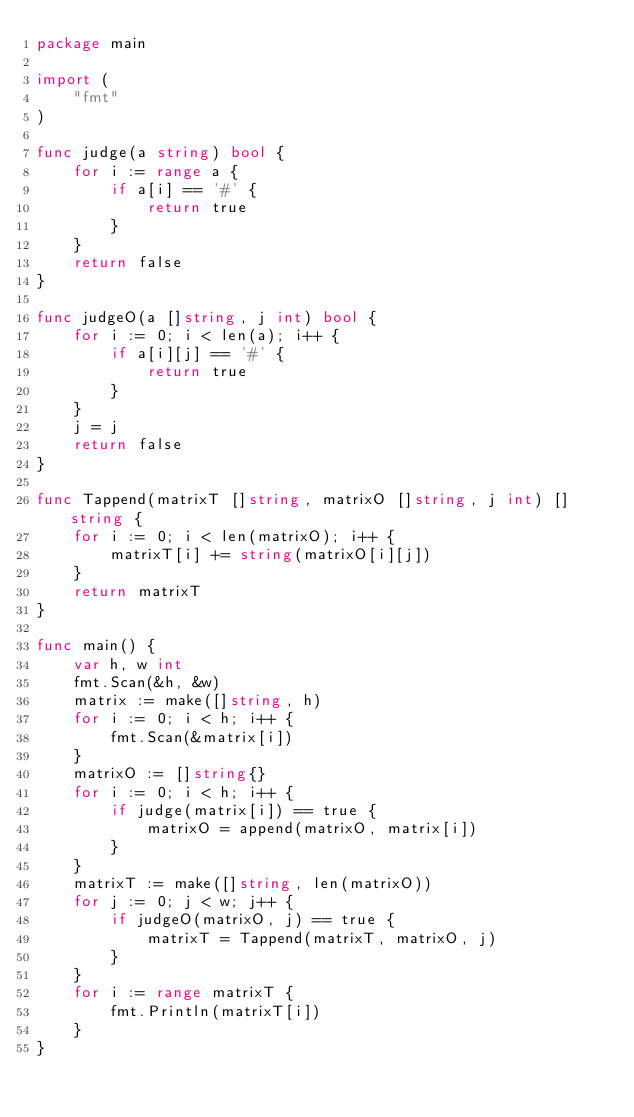<code> <loc_0><loc_0><loc_500><loc_500><_Go_>package main

import (
	"fmt"
)

func judge(a string) bool {
	for i := range a {
		if a[i] == '#' {
			return true
		}
	}
	return false
}

func judgeO(a []string, j int) bool {
	for i := 0; i < len(a); i++ {
		if a[i][j] == '#' {
			return true
		}
	}
	j = j
	return false
}

func Tappend(matrixT []string, matrixO []string, j int) []string {
	for i := 0; i < len(matrixO); i++ {
		matrixT[i] += string(matrixO[i][j])
	}
	return matrixT
}

func main() {
	var h, w int
	fmt.Scan(&h, &w)
	matrix := make([]string, h)
	for i := 0; i < h; i++ {
		fmt.Scan(&matrix[i])
	}
	matrixO := []string{}
	for i := 0; i < h; i++ {
		if judge(matrix[i]) == true {
			matrixO = append(matrixO, matrix[i])
		}
	}
	matrixT := make([]string, len(matrixO))
	for j := 0; j < w; j++ {
		if judgeO(matrixO, j) == true {
			matrixT = Tappend(matrixT, matrixO, j)
		}
	}
	for i := range matrixT {
		fmt.Println(matrixT[i])
	}
}
</code> 